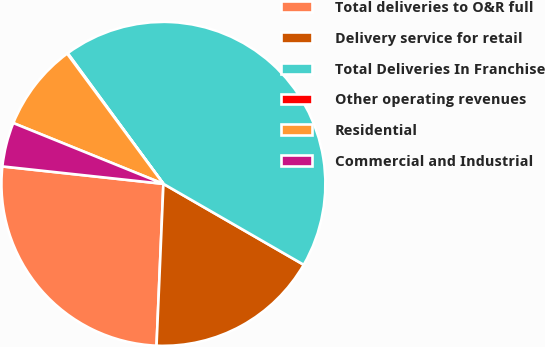<chart> <loc_0><loc_0><loc_500><loc_500><pie_chart><fcel>Total deliveries to O&R full<fcel>Delivery service for retail<fcel>Total Deliveries In Franchise<fcel>Other operating revenues<fcel>Residential<fcel>Commercial and Industrial<nl><fcel>26.04%<fcel>17.35%<fcel>43.39%<fcel>0.07%<fcel>8.74%<fcel>4.41%<nl></chart> 